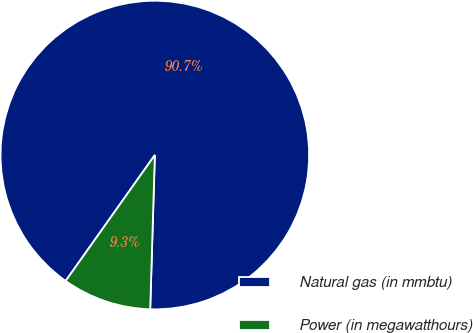<chart> <loc_0><loc_0><loc_500><loc_500><pie_chart><fcel>Natural gas (in mmbtu)<fcel>Power (in megawatthours)<nl><fcel>90.67%<fcel>9.33%<nl></chart> 